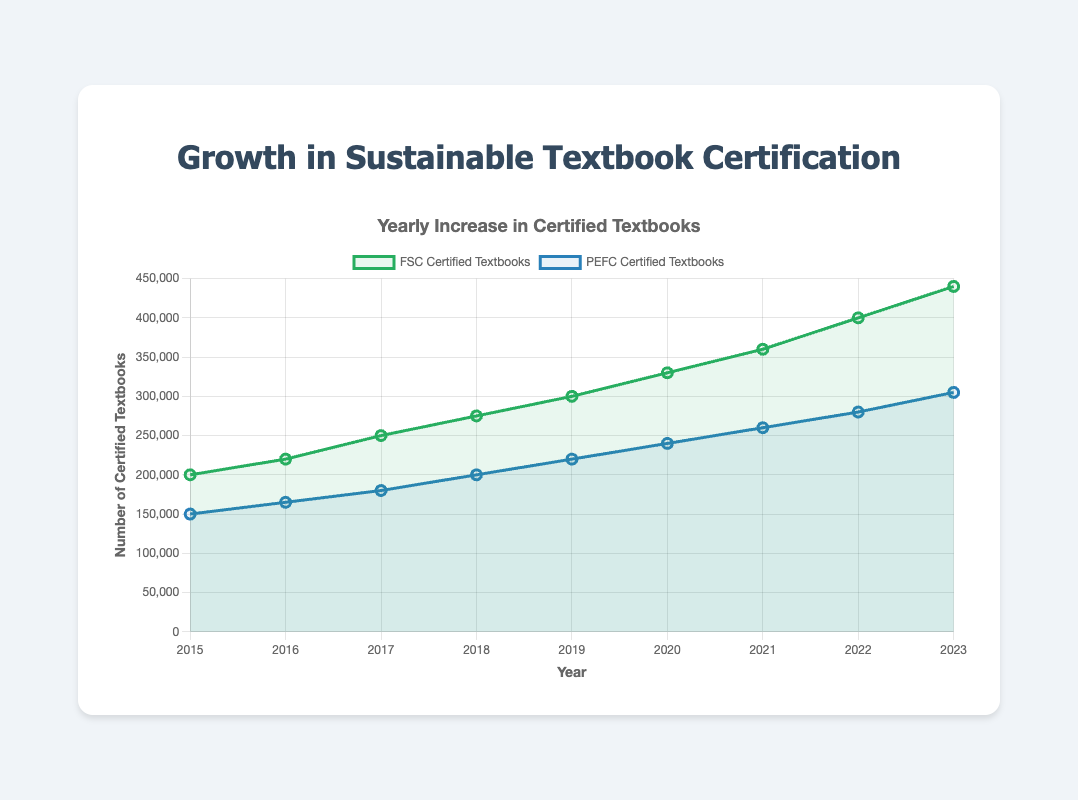What is the trend in the number of FSC certified textbooks from 2015 to 2023? The number of FSC certified textbooks increases consistently every year from 200,000 in 2015 to 440,000 in 2023.
Answer: Increasing Which year saw the highest number of PEFC certified textbooks? The year 2023 has the highest number of PEFC certified textbooks, with 305,000 certificates.
Answer: 2023 By how much did the number of FSC certified textbooks increase from 2018 to 2023? In 2018, the number of FSC certified textbooks was 275,000, and in 2023 it was 440,000. The increase is 440,000 - 275,000 = 165,000.
Answer: 165,000 How does the increase in PEFC certified textbooks from 2015 to 2023 compare to the increase in FSC certified textbooks for the same period? In 2015, the number of PEFC certified textbooks was 150,000 and in 2023 it was 305,000, so the increase is 305,000 - 150,000 = 155,000. For FSC certified textbooks, the increase is from 200,000 in 2015 to 440,000 in 2023, i.e., 440,000 - 200,000 = 240,000. Comparing the increases, 240,000 (FSC) is greater than 155,000 (PEFC).
Answer: FSC certified textbooks increased more In which year did the number of FSC certified textbooks surpass 300,000? The number of FSC certified textbooks surpassed 300,000 in the year 2019, as they reached 300,000 that year.
Answer: 2019 What is the average yearly increase in PEFC certified textbooks between 2015 and 2023? The increase from 2015 to 2023 is 305,000 - 150,000 = 155,000. There are 8 intervals between 2015 and 2023. The average yearly increase is 155,000 / 8 = 19,375.
Answer: 19,375 Compare the overall trend of FSC certified textbooks with PEFC certified textbooks from 2015 to 2023. Both FSC and PEFC certified textbooks show an increasing trend from 2015 to 2023. FSC certified textbooks increase from 200,000 to 440,000, and PEFC certified textbooks increase from 150,000 to 305,000. While both increase, the growth rate of FSC certified textbooks is higher than that of PEFC certified textbooks.
Answer: Both increasing, FSC higher growth What was the difference in the number of FSC and PEFC certified textbooks in the year 2022? In 2022, FSC certified textbooks were 400,000 and PEFC certified textbooks were 280,000. The difference is 400,000 - 280,000 = 120,000.
Answer: 120,000 Which certification had a steeper incline in textbook numbers between 2019 and 2023? From 2019 to 2023, the increase for FSC certified textbooks was from 300,000 to 440,000, a difference of 140,000. For PEFC, the increase was from 220,000 to 305,000, a difference of 85,000. FSC had a steeper incline.
Answer: FSC 